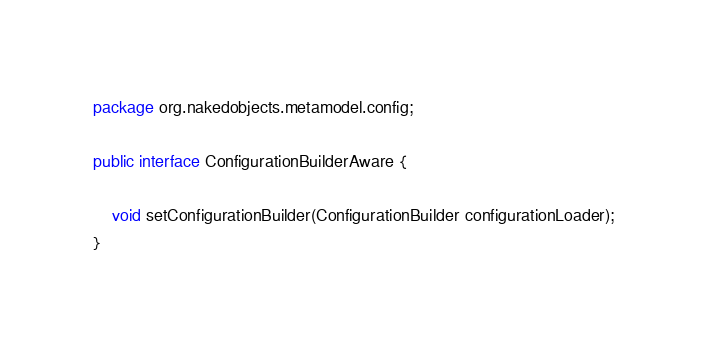<code> <loc_0><loc_0><loc_500><loc_500><_Java_>package org.nakedobjects.metamodel.config;

public interface ConfigurationBuilderAware {

	void setConfigurationBuilder(ConfigurationBuilder configurationLoader);
}
</code> 